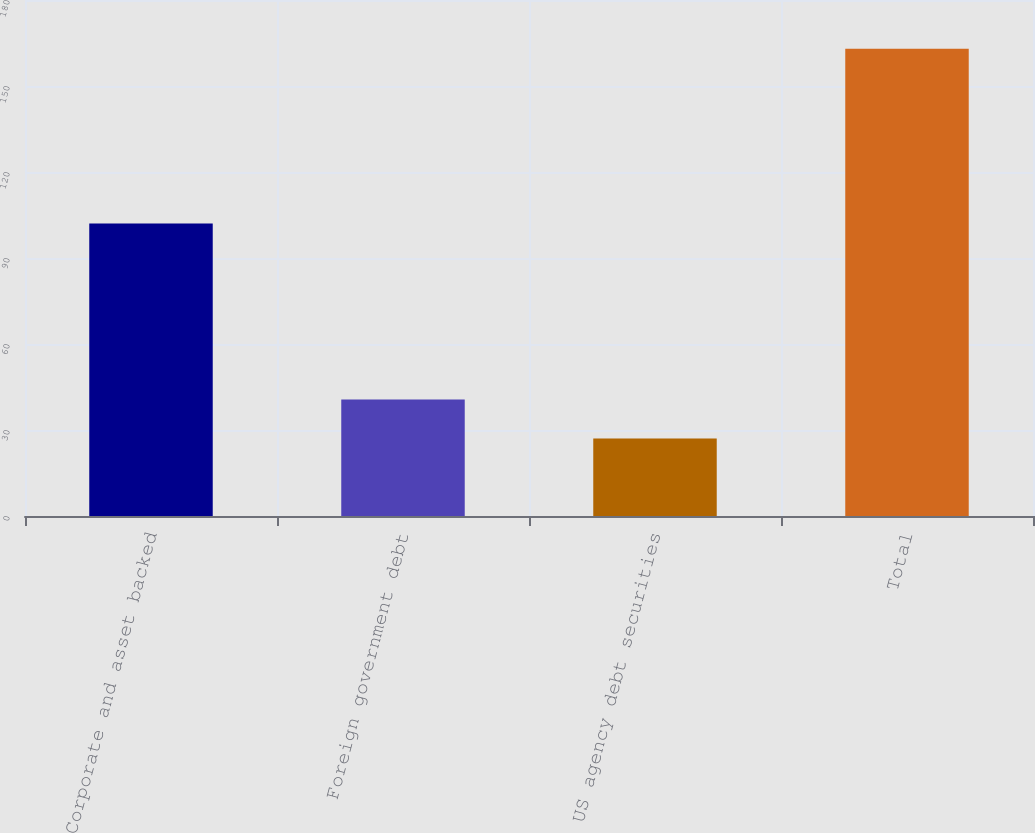Convert chart. <chart><loc_0><loc_0><loc_500><loc_500><bar_chart><fcel>Corporate and asset backed<fcel>Foreign government debt<fcel>US agency debt securities<fcel>Total<nl><fcel>102<fcel>40.6<fcel>27<fcel>163<nl></chart> 